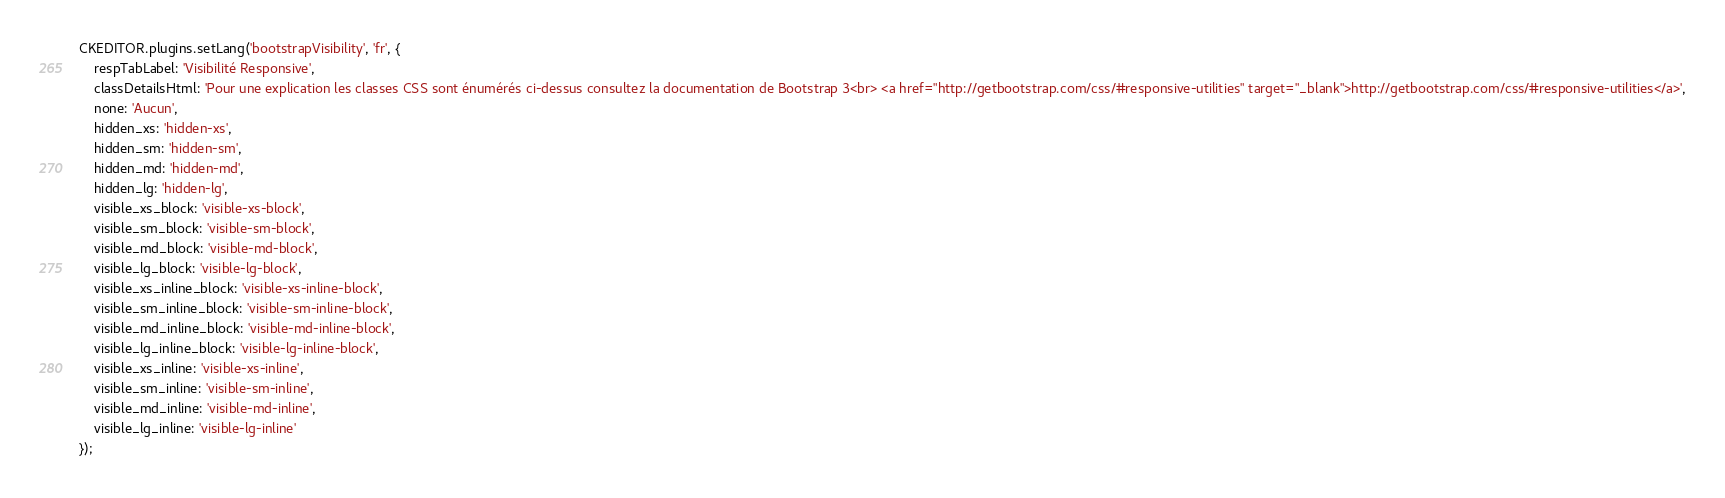<code> <loc_0><loc_0><loc_500><loc_500><_JavaScript_>CKEDITOR.plugins.setLang('bootstrapVisibility', 'fr', {
	respTabLabel: 'Visibilité Responsive',
	classDetailsHtml: 'Pour une explication les classes CSS sont énumérés ci-dessus consultez la documentation de Bootstrap 3<br> <a href="http://getbootstrap.com/css/#responsive-utilities" target="_blank">http://getbootstrap.com/css/#responsive-utilities</a>',
	none: 'Aucun',
	hidden_xs: 'hidden-xs',
	hidden_sm: 'hidden-sm',
	hidden_md: 'hidden-md',
	hidden_lg: 'hidden-lg',
	visible_xs_block: 'visible-xs-block',
	visible_sm_block: 'visible-sm-block',
	visible_md_block: 'visible-md-block',
	visible_lg_block: 'visible-lg-block',
	visible_xs_inline_block: 'visible-xs-inline-block',
	visible_sm_inline_block: 'visible-sm-inline-block',
	visible_md_inline_block: 'visible-md-inline-block',
	visible_lg_inline_block: 'visible-lg-inline-block',
	visible_xs_inline: 'visible-xs-inline',
	visible_sm_inline: 'visible-sm-inline',
	visible_md_inline: 'visible-md-inline',
	visible_lg_inline: 'visible-lg-inline'
});</code> 